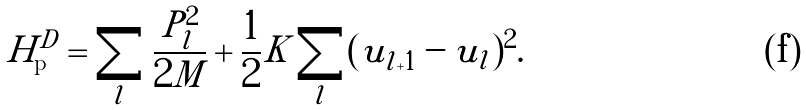Convert formula to latex. <formula><loc_0><loc_0><loc_500><loc_500>H ^ { D } _ { \text {p} } = \sum _ { l } \frac { P _ { l } ^ { 2 } } { 2 M } + \frac { 1 } { 2 } K \sum _ { l } ( u _ { l + 1 } - u _ { l } ) ^ { 2 } .</formula> 